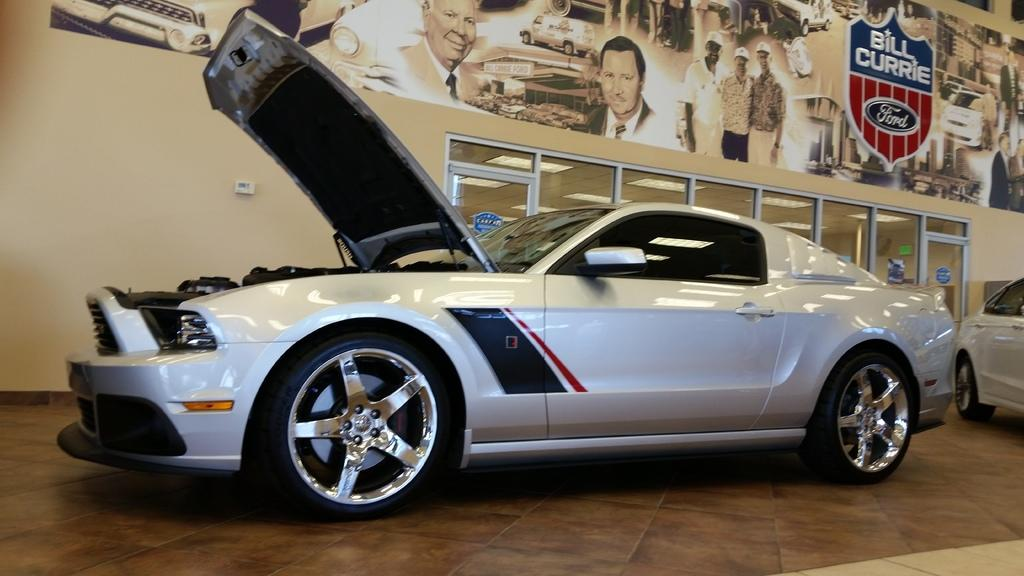What objects are on the floor in the image? There are vehicles on the floor in the image. What can be seen in the background of the image? There is a poster in the background of the image. What type of doors are visible in the image? There are glass doors in the image. What architectural feature is present in the image? There is a wall in the image. What type of tooth is visible on the wall in the image? There is no tooth present on the wall in the image. 